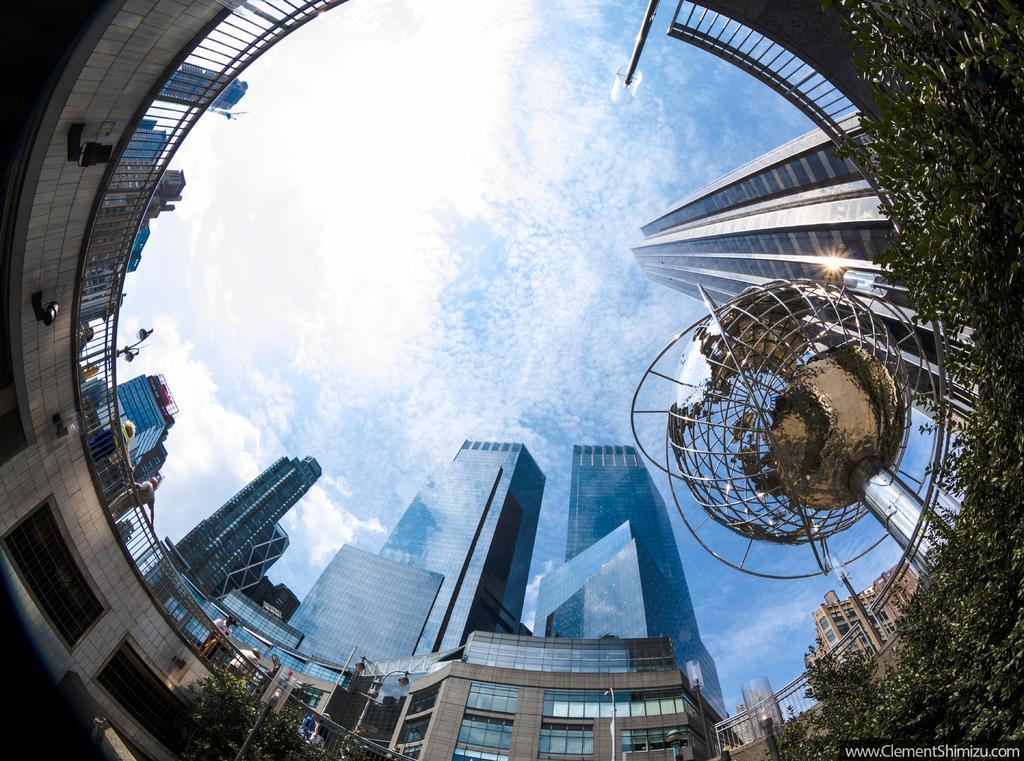Please provide a concise description of this image. In this image we can see buildings, skyscrapers, trees and sky with clouds. 